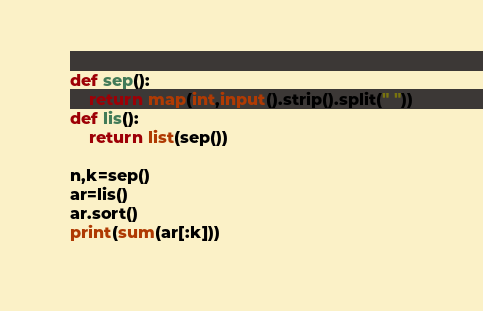<code> <loc_0><loc_0><loc_500><loc_500><_Python_>def sep():
    return map(int,input().strip().split(" "))
def lis():
    return list(sep())

n,k=sep()
ar=lis()
ar.sort()
print(sum(ar[:k]))</code> 